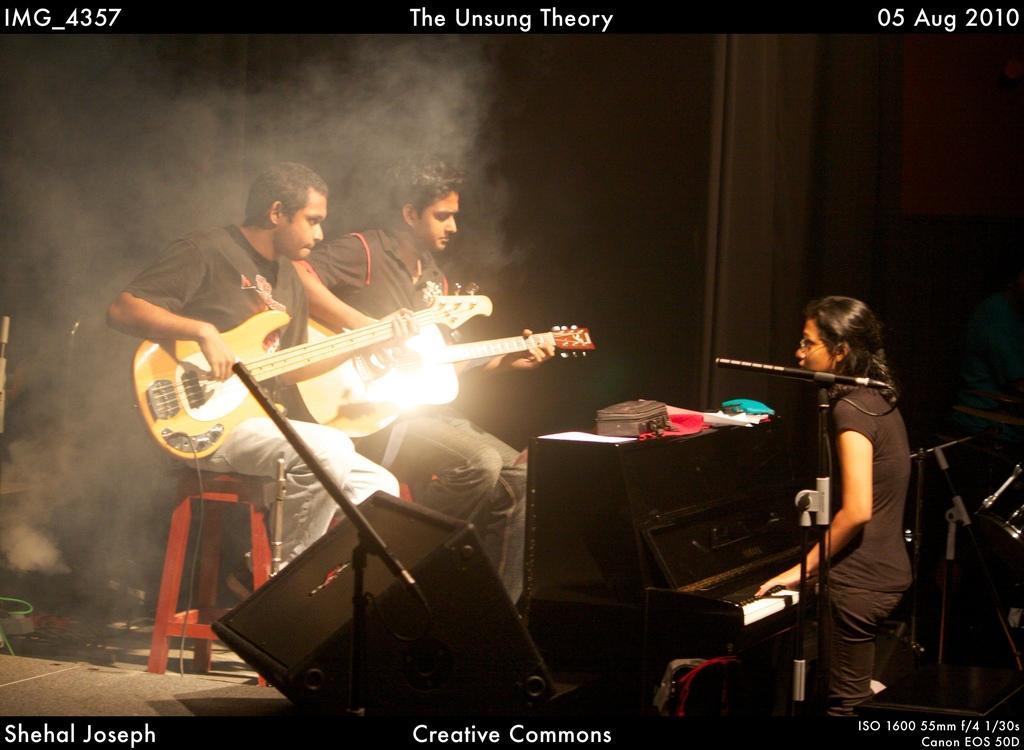In one or two sentences, can you explain what this image depicts? In the center we can see two persons were sitting on the stool and holding guitar. On the right we can see one woman standing and holding keyboard. In the bottom there is a speaker and microphone. In the background we can see wall. 